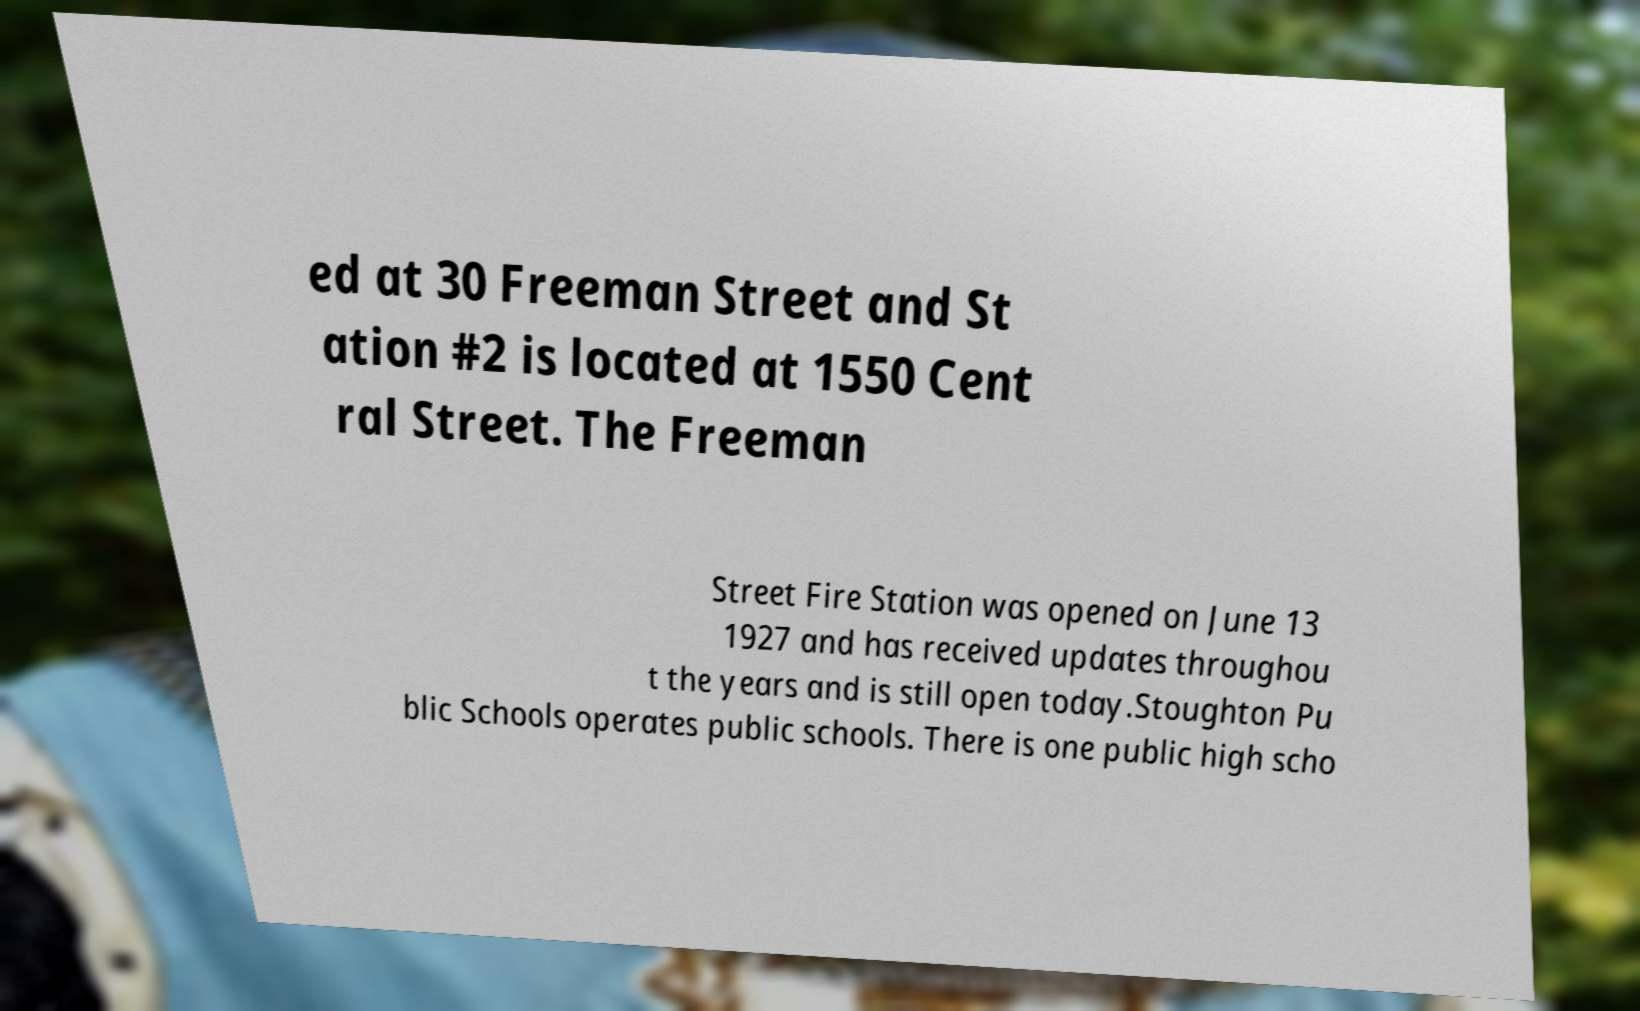There's text embedded in this image that I need extracted. Can you transcribe it verbatim? ed at 30 Freeman Street and St ation #2 is located at 1550 Cent ral Street. The Freeman Street Fire Station was opened on June 13 1927 and has received updates throughou t the years and is still open today.Stoughton Pu blic Schools operates public schools. There is one public high scho 